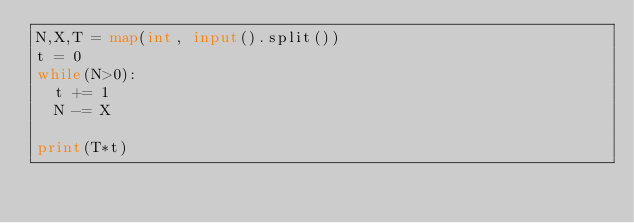<code> <loc_0><loc_0><loc_500><loc_500><_Python_>N,X,T = map(int, input().split())
t = 0
while(N>0):
  t += 1
  N -= X

print(T*t)</code> 